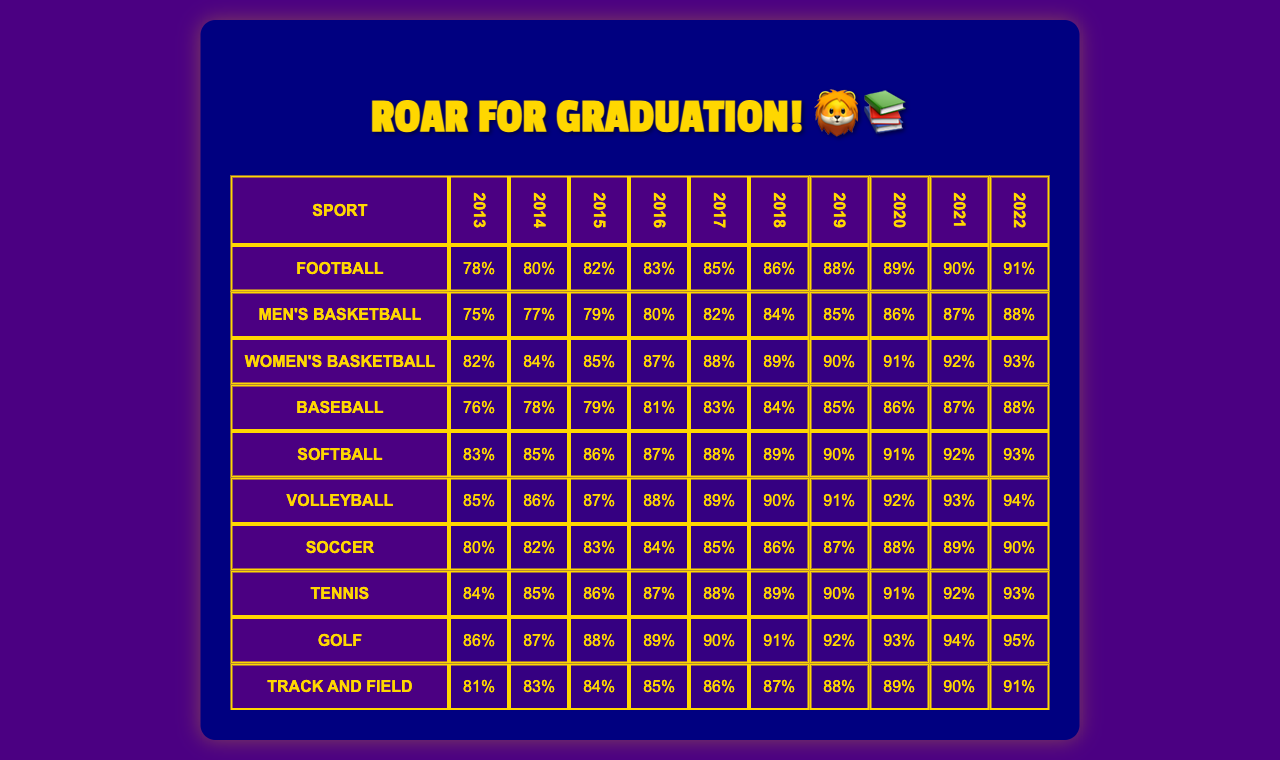What is the graduation rate for Men's Basketball in 2022? Looking at the table under the Men's Basketball row and the 2022 column, the graduation rate is 88%.
Answer: 88% Which sport had the highest graduation rate in 2021? Checking the 2021 column across all sports, the highest graduation rate is 95% for Golf.
Answer: Golf What was the average graduation rate for Softball over the last decade? The graduation rates for Softball from 2013 to 2022 are 83, 85, 86, 87, 88, 89, 90, 91, 92, and 93. Adding these gives 882. Dividing by 10 results in an average of 88.2.
Answer: 88.2 Did Volleyball's graduation rate ever drop below 85% from 2013 to 2022? Reviewing the Volleyball row, the graduation rates are 85, 86, 87, 88, 89, 90, 91, 92, 93, and 94. Since the lowest rate is 85, it never dropped below this threshold.
Answer: No Which sport had the most significant increase in graduation rate from 2013 to 2022? The graduation rates for Football in 2013 is 78% and in 2022 is 91%, making an increase of 13. For Softball, the rates are 83% in 2013 and 93% in 2022, an increase of 10. For all sports, Football had the largest increase.
Answer: Football What was the graduation rate for Soccer in 2018? From the table, looking at the Soccer row for the year 2018, the graduation rate is 86%.
Answer: 86% Is the graduation rate for Women's Basketball higher than that of Men's Basketball in 2019? For Women's Basketball in 2019, the rate is 90%, while for Men's Basketball, it is 85%. Thus, Women's Basketball has a higher graduation rate.
Answer: Yes What is the difference in graduation rates between Golf and Track and Field in 2020? For Golf in 2020, the graduation rate is 91% and for Track and Field, it's 89%. The difference is 91 - 89 = 2.
Answer: 2 Identify the sport with the lowest graduation rate in 2016. In 2016, the graduation rates are 83 for Football, 80 for Men's Basketball, 87 for Women's Basketball, 81 for Baseball, 87 for Softball, 88 for Volleyball, 84 for Soccer, 87 for Tennis, 89 for Golf, and 85 for Track and Field. Therefore, Men's Basketball has the lowest rate.
Answer: Men's Basketball What was the graduation rate trend for Baseball over the past decade? Baseball's graduation rates start from 76% in 2013 to 88% in 2022, showing a steady increase each year.
Answer: Steady increase Did any sport have a graduation rate of 90% or more in every year? Looking through each sport, no sport consistently had a graduation rate of 90% or higher every year, as the rates fluctuate.
Answer: No 